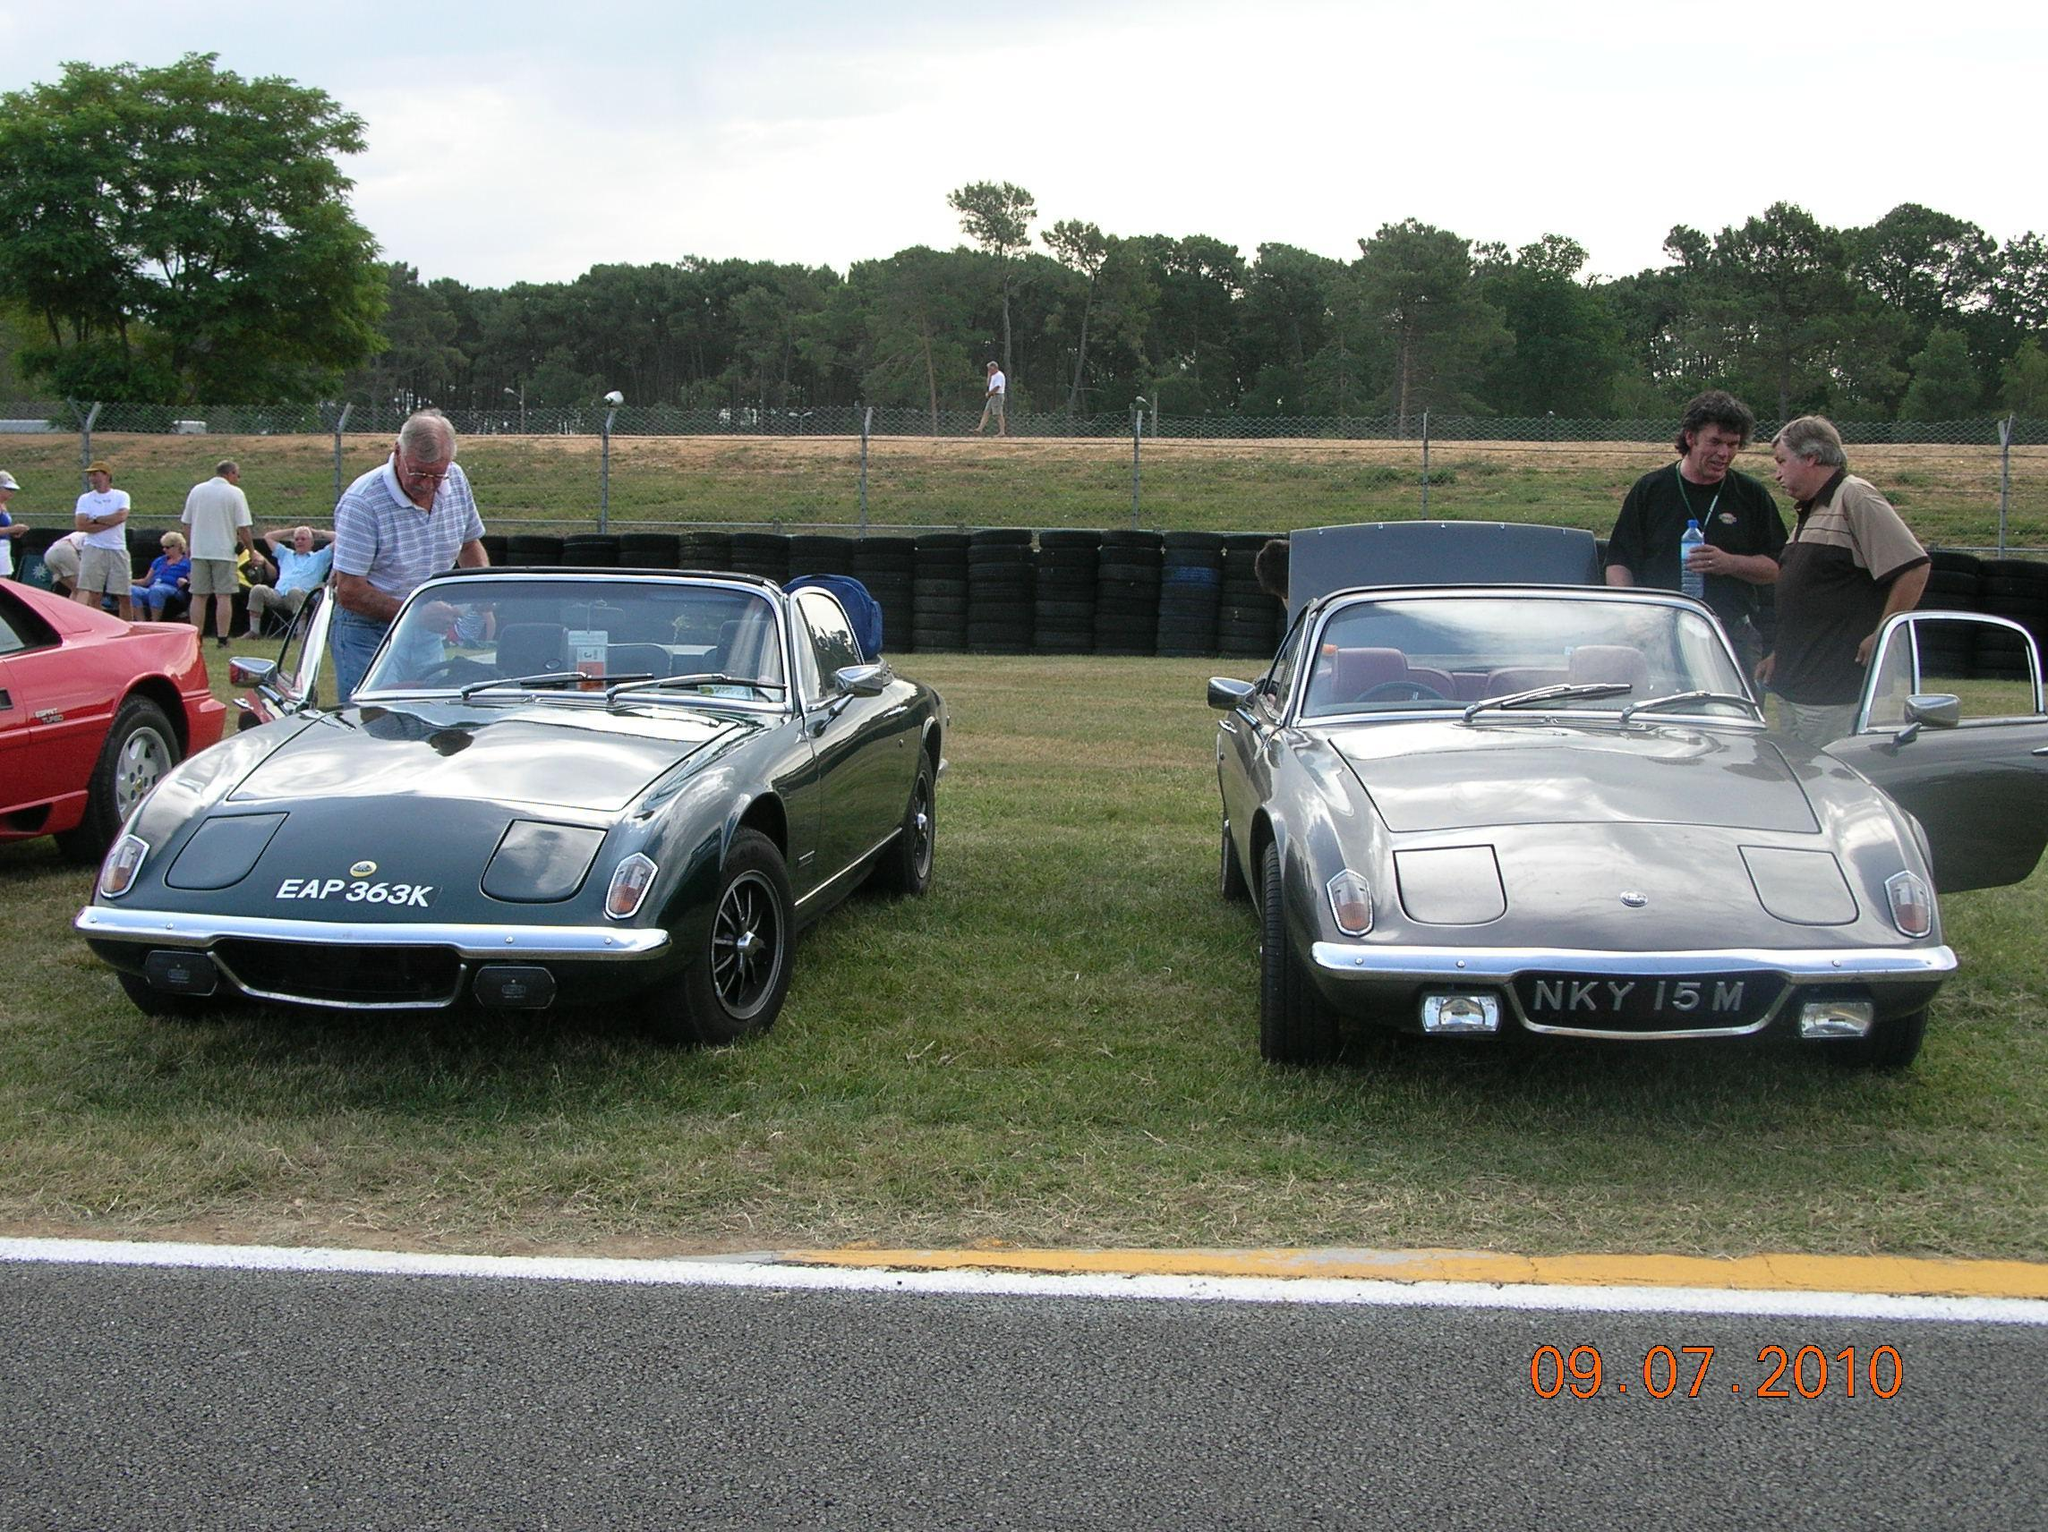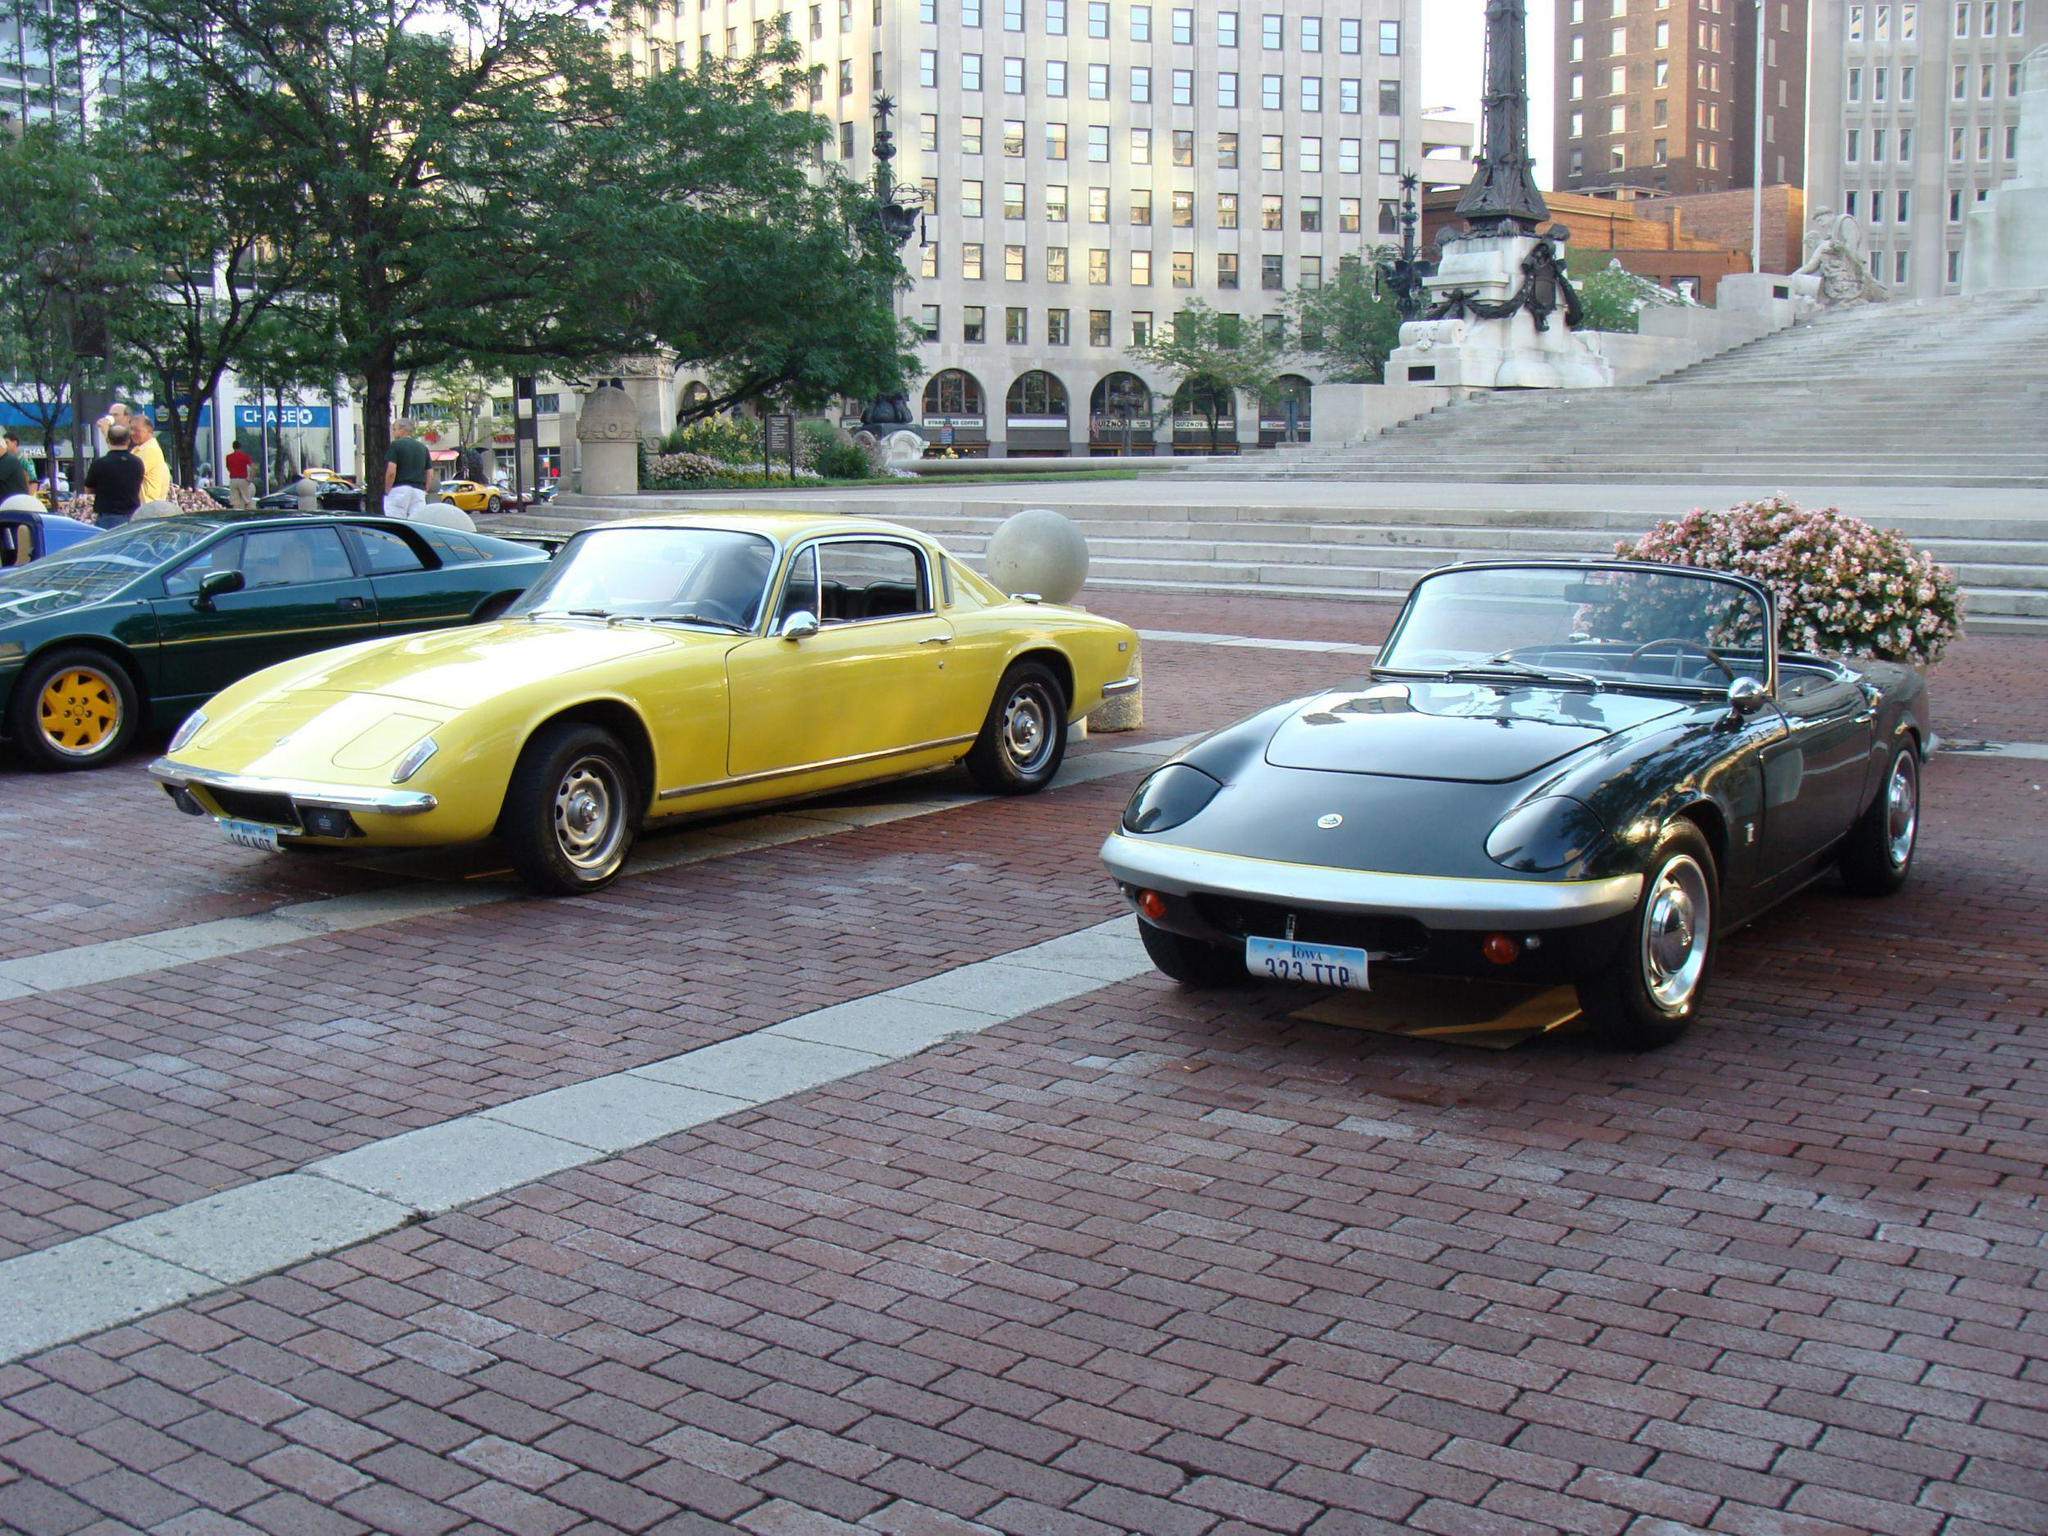The first image is the image on the left, the second image is the image on the right. Examine the images to the left and right. Is the description "In one image, at least one car is parked on a brick pavement." accurate? Answer yes or no. Yes. 